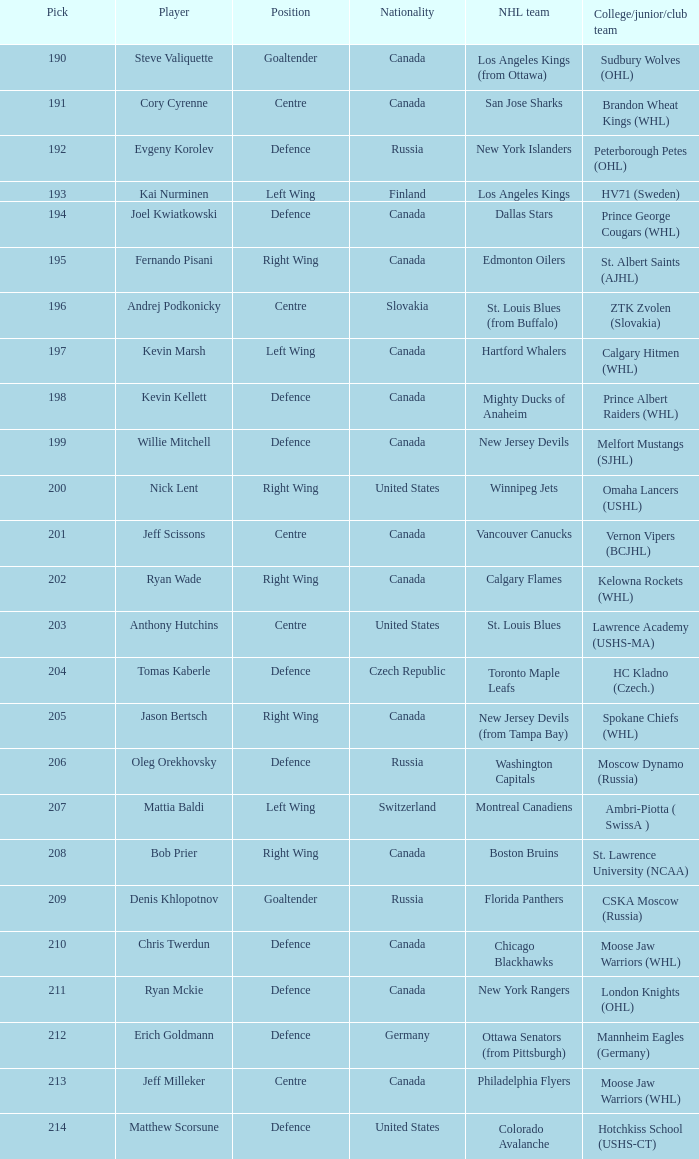Name the college for andrej podkonicky ZTK Zvolen (Slovakia). Help me parse the entirety of this table. {'header': ['Pick', 'Player', 'Position', 'Nationality', 'NHL team', 'College/junior/club team'], 'rows': [['190', 'Steve Valiquette', 'Goaltender', 'Canada', 'Los Angeles Kings (from Ottawa)', 'Sudbury Wolves (OHL)'], ['191', 'Cory Cyrenne', 'Centre', 'Canada', 'San Jose Sharks', 'Brandon Wheat Kings (WHL)'], ['192', 'Evgeny Korolev', 'Defence', 'Russia', 'New York Islanders', 'Peterborough Petes (OHL)'], ['193', 'Kai Nurminen', 'Left Wing', 'Finland', 'Los Angeles Kings', 'HV71 (Sweden)'], ['194', 'Joel Kwiatkowski', 'Defence', 'Canada', 'Dallas Stars', 'Prince George Cougars (WHL)'], ['195', 'Fernando Pisani', 'Right Wing', 'Canada', 'Edmonton Oilers', 'St. Albert Saints (AJHL)'], ['196', 'Andrej Podkonicky', 'Centre', 'Slovakia', 'St. Louis Blues (from Buffalo)', 'ZTK Zvolen (Slovakia)'], ['197', 'Kevin Marsh', 'Left Wing', 'Canada', 'Hartford Whalers', 'Calgary Hitmen (WHL)'], ['198', 'Kevin Kellett', 'Defence', 'Canada', 'Mighty Ducks of Anaheim', 'Prince Albert Raiders (WHL)'], ['199', 'Willie Mitchell', 'Defence', 'Canada', 'New Jersey Devils', 'Melfort Mustangs (SJHL)'], ['200', 'Nick Lent', 'Right Wing', 'United States', 'Winnipeg Jets', 'Omaha Lancers (USHL)'], ['201', 'Jeff Scissons', 'Centre', 'Canada', 'Vancouver Canucks', 'Vernon Vipers (BCJHL)'], ['202', 'Ryan Wade', 'Right Wing', 'Canada', 'Calgary Flames', 'Kelowna Rockets (WHL)'], ['203', 'Anthony Hutchins', 'Centre', 'United States', 'St. Louis Blues', 'Lawrence Academy (USHS-MA)'], ['204', 'Tomas Kaberle', 'Defence', 'Czech Republic', 'Toronto Maple Leafs', 'HC Kladno (Czech.)'], ['205', 'Jason Bertsch', 'Right Wing', 'Canada', 'New Jersey Devils (from Tampa Bay)', 'Spokane Chiefs (WHL)'], ['206', 'Oleg Orekhovsky', 'Defence', 'Russia', 'Washington Capitals', 'Moscow Dynamo (Russia)'], ['207', 'Mattia Baldi', 'Left Wing', 'Switzerland', 'Montreal Canadiens', 'Ambri-Piotta ( SwissA )'], ['208', 'Bob Prier', 'Right Wing', 'Canada', 'Boston Bruins', 'St. Lawrence University (NCAA)'], ['209', 'Denis Khlopotnov', 'Goaltender', 'Russia', 'Florida Panthers', 'CSKA Moscow (Russia)'], ['210', 'Chris Twerdun', 'Defence', 'Canada', 'Chicago Blackhawks', 'Moose Jaw Warriors (WHL)'], ['211', 'Ryan Mckie', 'Defence', 'Canada', 'New York Rangers', 'London Knights (OHL)'], ['212', 'Erich Goldmann', 'Defence', 'Germany', 'Ottawa Senators (from Pittsburgh)', 'Mannheim Eagles (Germany)'], ['213', 'Jeff Milleker', 'Centre', 'Canada', 'Philadelphia Flyers', 'Moose Jaw Warriors (WHL)'], ['214', 'Matthew Scorsune', 'Defence', 'United States', 'Colorado Avalanche', 'Hotchkiss School (USHS-CT)']]} 